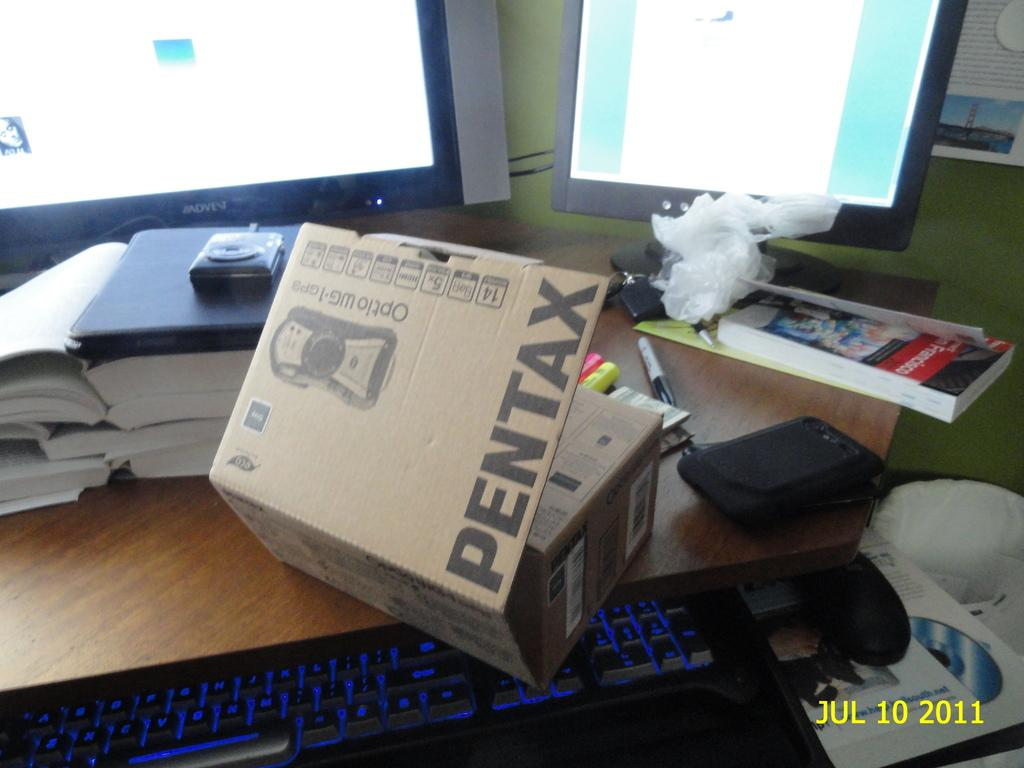<image>
Provide a brief description of the given image. Opening a pentax camera on a messy desk that has 2 monitors, books and what looks like garbage on it. 